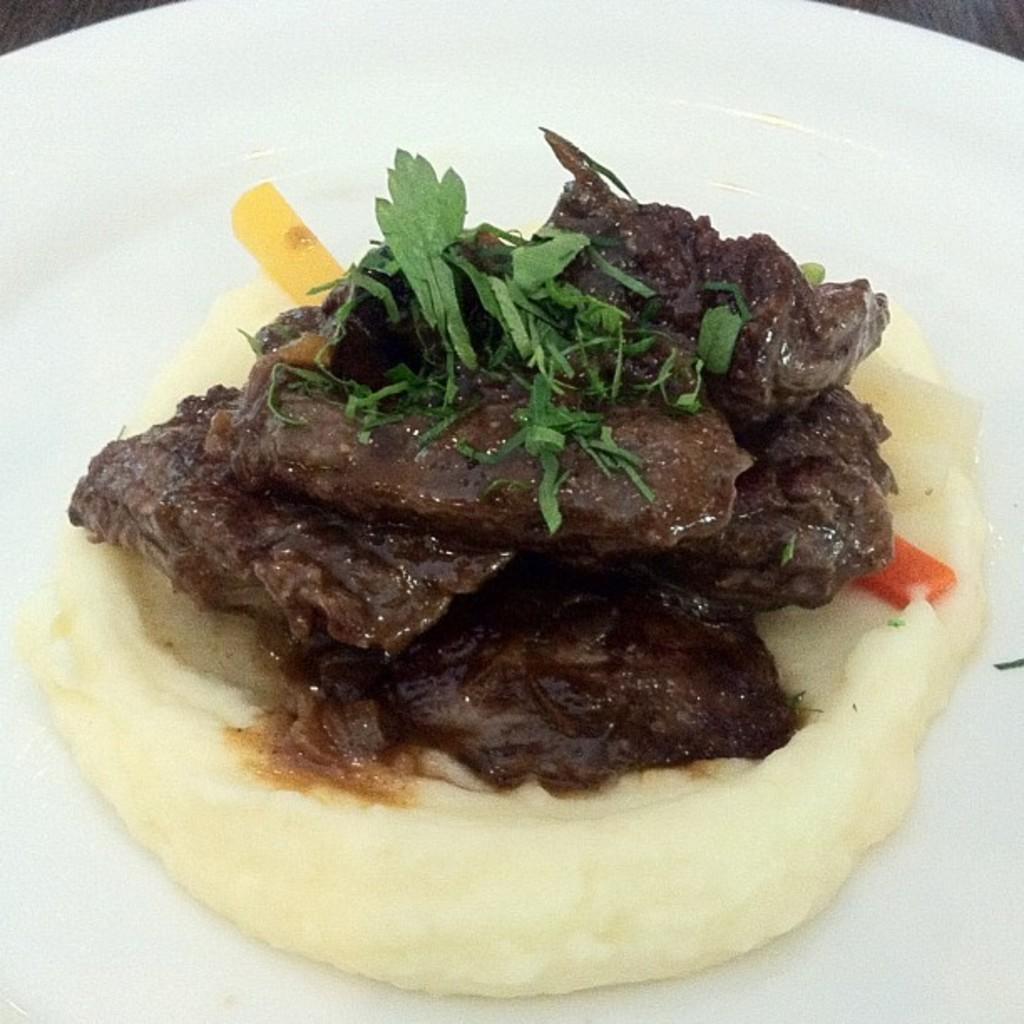Could you give a brief overview of what you see in this image? In this picture we can see some eatable item is placed on the table. 